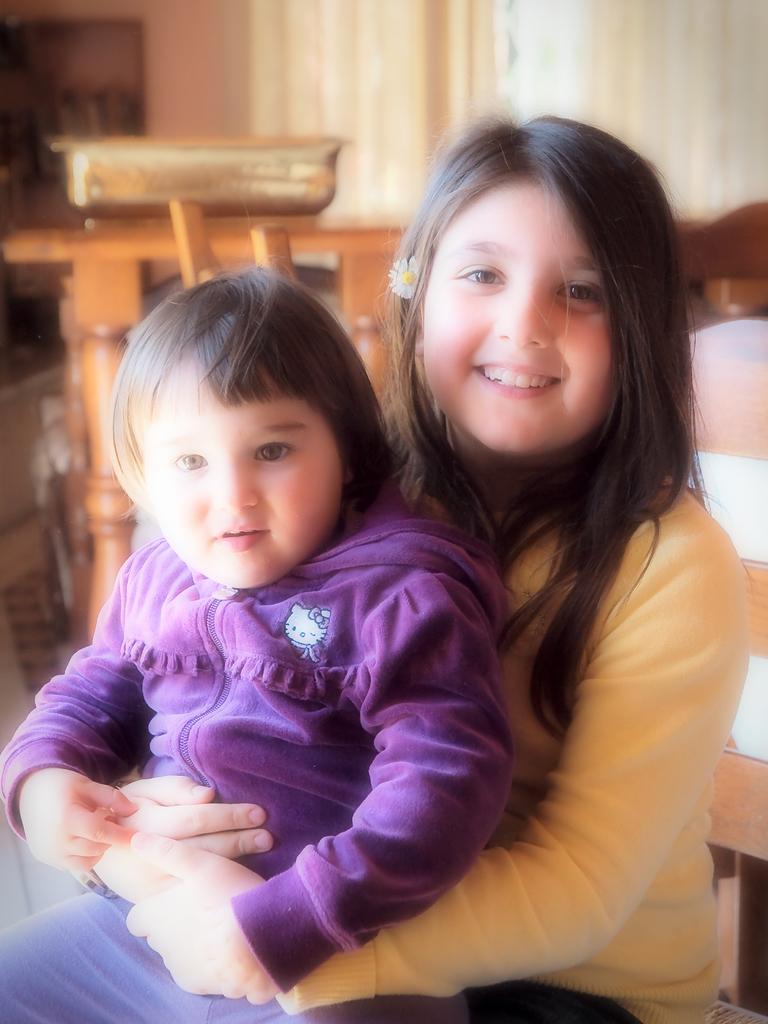Describe this image in one or two sentences. The girl in this picture wearing a yellow jacket is holding the girl who is wearing a purple jacket and both of them are smiling. She is sitting on the chair. Behind her, we see a bed and a table on which vessel is placed. Behind that, we see a white curtain and a wall on which photo frame is placed. This picture is clicked inside the room. 